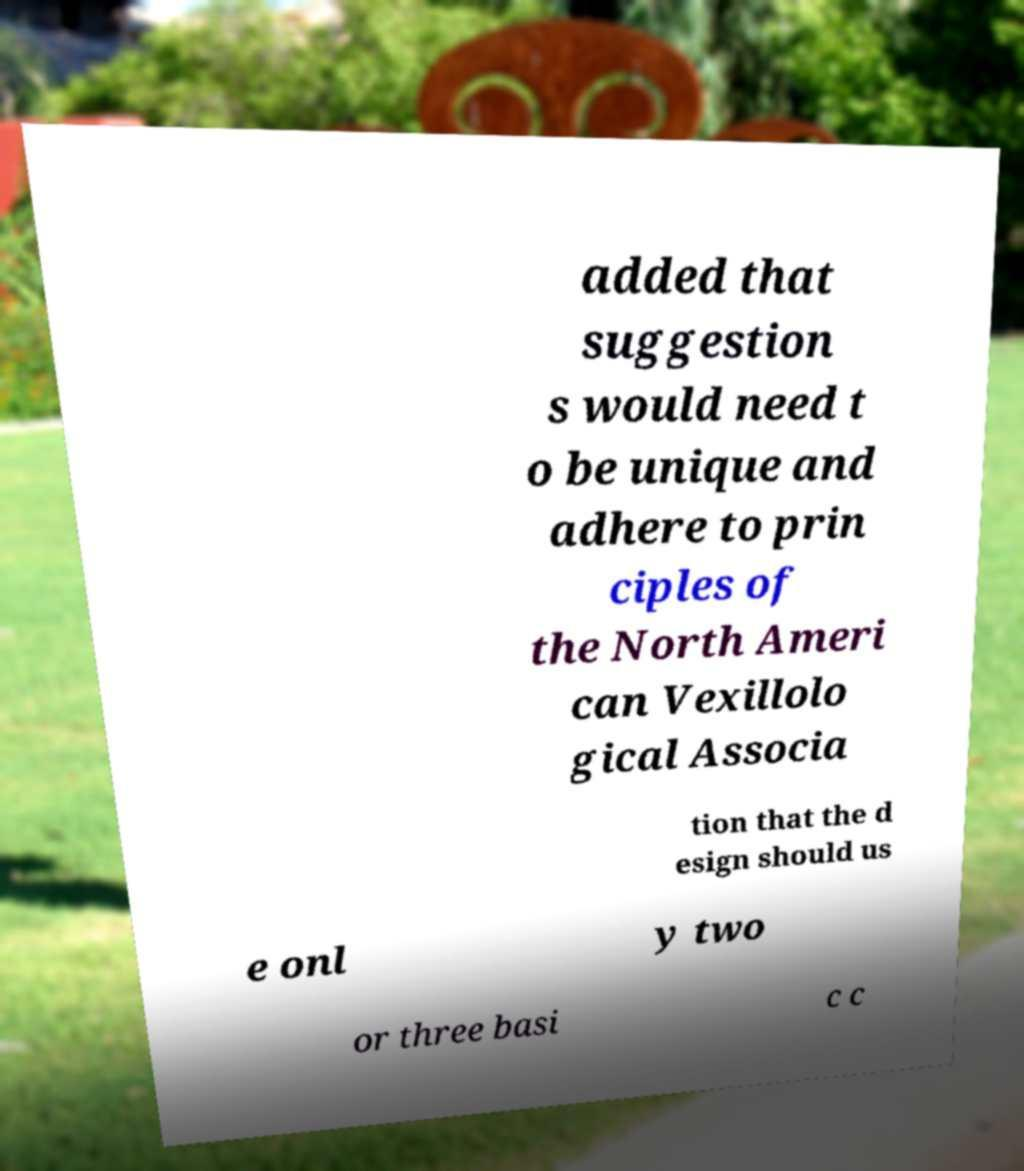Can you read and provide the text displayed in the image?This photo seems to have some interesting text. Can you extract and type it out for me? added that suggestion s would need t o be unique and adhere to prin ciples of the North Ameri can Vexillolo gical Associa tion that the d esign should us e onl y two or three basi c c 